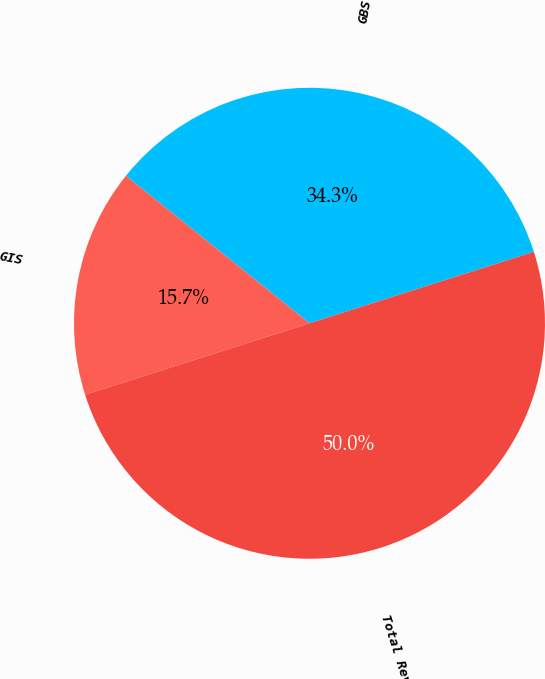Convert chart. <chart><loc_0><loc_0><loc_500><loc_500><pie_chart><fcel>GBS<fcel>GIS<fcel>Total Revenues<nl><fcel>34.32%<fcel>15.68%<fcel>50.0%<nl></chart> 